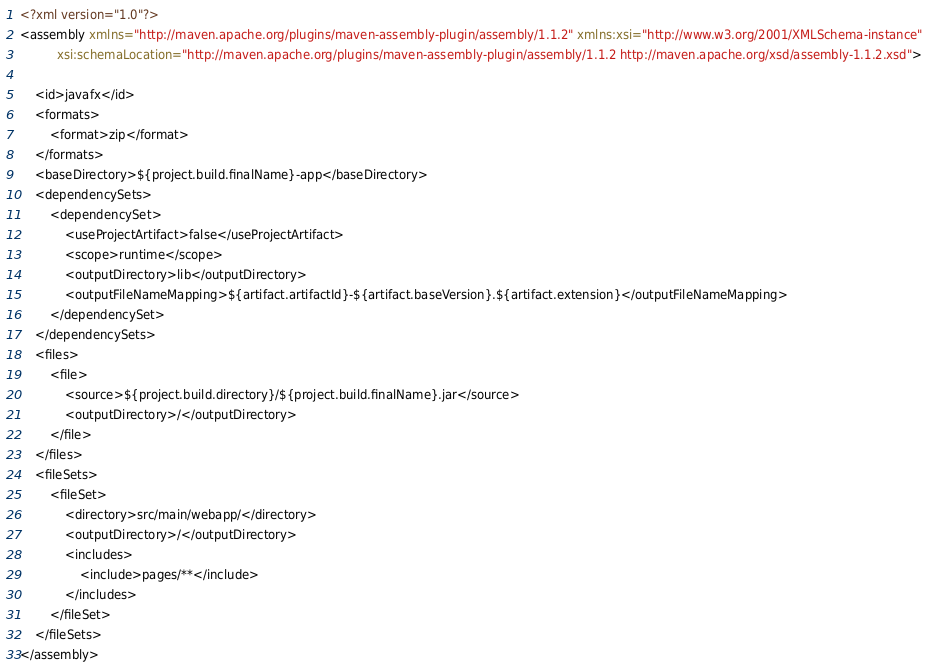<code> <loc_0><loc_0><loc_500><loc_500><_XML_><?xml version="1.0"?>
<assembly xmlns="http://maven.apache.org/plugins/maven-assembly-plugin/assembly/1.1.2" xmlns:xsi="http://www.w3.org/2001/XMLSchema-instance"
          xsi:schemaLocation="http://maven.apache.org/plugins/maven-assembly-plugin/assembly/1.1.2 http://maven.apache.org/xsd/assembly-1.1.2.xsd">
  
    <id>javafx</id>
    <formats>
        <format>zip</format>
    </formats>
    <baseDirectory>${project.build.finalName}-app</baseDirectory>
    <dependencySets>
        <dependencySet>
            <useProjectArtifact>false</useProjectArtifact>
            <scope>runtime</scope>
            <outputDirectory>lib</outputDirectory>
            <outputFileNameMapping>${artifact.artifactId}-${artifact.baseVersion}.${artifact.extension}</outputFileNameMapping>
        </dependencySet>
    </dependencySets> 
    <files>
        <file>
            <source>${project.build.directory}/${project.build.finalName}.jar</source>
            <outputDirectory>/</outputDirectory>
        </file>
    </files>
    <fileSets>
        <fileSet>
            <directory>src/main/webapp/</directory>
            <outputDirectory>/</outputDirectory>
            <includes>
                <include>pages/**</include>
            </includes>
        </fileSet>
    </fileSets>
</assembly></code> 